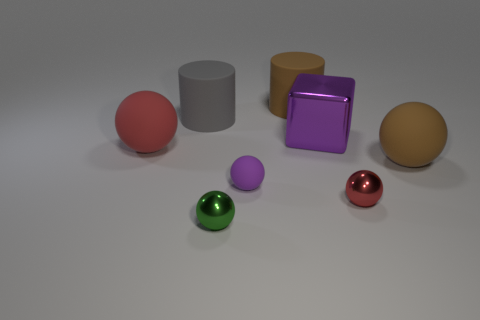There is a gray object that is the same size as the brown matte cylinder; what shape is it?
Your answer should be compact. Cylinder. There is a big brown matte thing in front of the big block; does it have the same shape as the brown object that is left of the large purple metallic object?
Your response must be concise. No. What is the big sphere that is right of the large sphere that is left of the big brown ball made of?
Provide a short and direct response. Rubber. Are the small green sphere that is in front of the large brown rubber cylinder and the big purple object made of the same material?
Give a very brief answer. Yes. There is a brown matte object that is to the left of the brown matte ball; what is its size?
Offer a terse response. Large. There is a brown ball that is on the right side of the small purple rubber sphere; is there a block that is right of it?
Your answer should be very brief. No. Is the color of the large matte ball that is right of the big red rubber object the same as the cylinder on the right side of the small purple matte ball?
Provide a short and direct response. Yes. The big shiny object is what color?
Make the answer very short. Purple. Is there anything else that is the same color as the small matte thing?
Offer a very short reply. Yes. There is a ball that is both on the left side of the small red metallic thing and behind the small purple rubber object; what is its color?
Offer a very short reply. Red. 